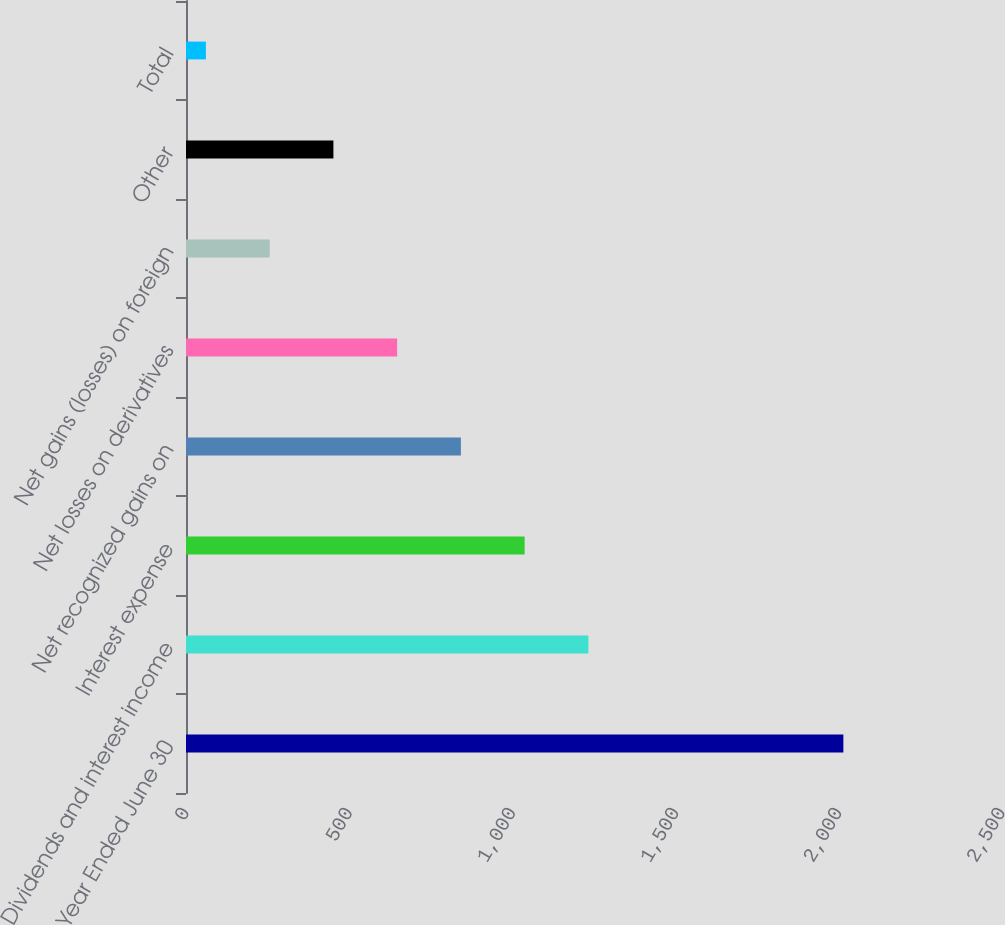Convert chart. <chart><loc_0><loc_0><loc_500><loc_500><bar_chart><fcel>Year Ended June 30<fcel>Dividends and interest income<fcel>Interest expense<fcel>Net recognized gains on<fcel>Net losses on derivatives<fcel>Net gains (losses) on foreign<fcel>Other<fcel>Total<nl><fcel>2014<fcel>1232.8<fcel>1037.5<fcel>842.2<fcel>646.9<fcel>256.3<fcel>451.6<fcel>61<nl></chart> 